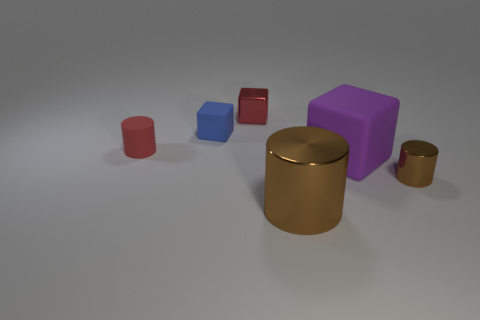Subtract all cyan cubes. How many brown cylinders are left? 2 Subtract all shiny cylinders. How many cylinders are left? 1 Add 2 small red metallic blocks. How many objects exist? 8 Subtract 0 blue balls. How many objects are left? 6 Subtract all small green metallic spheres. Subtract all red objects. How many objects are left? 4 Add 6 small red cubes. How many small red cubes are left? 7 Add 1 large metallic things. How many large metallic things exist? 2 